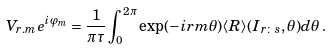<formula> <loc_0><loc_0><loc_500><loc_500>V _ { r . m } e ^ { i \varphi _ { m } } = \frac { 1 } { \pi \tau } \int _ { 0 } ^ { 2 \pi } \exp ( - i r m \theta ) \langle R \rangle ( I _ { r \colon s } , \theta ) d \theta \, .</formula> 